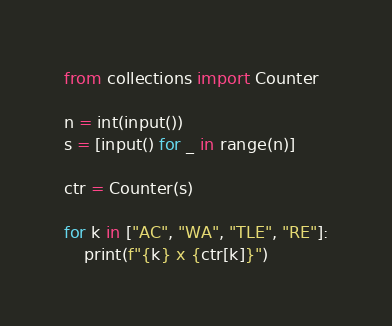Convert code to text. <code><loc_0><loc_0><loc_500><loc_500><_Python_>from collections import Counter

n = int(input())
s = [input() for _ in range(n)]

ctr = Counter(s)

for k in ["AC", "WA", "TLE", "RE"]:
    print(f"{k} x {ctr[k]}")

</code> 